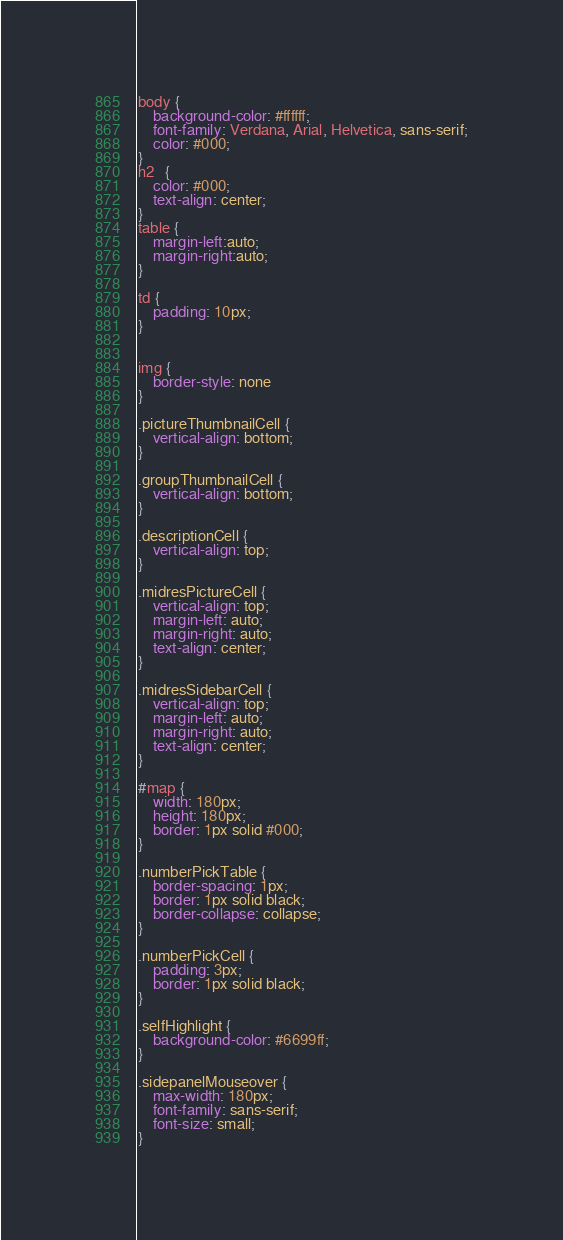Convert code to text. <code><loc_0><loc_0><loc_500><loc_500><_CSS_>body {
    background-color: #ffffff;
    font-family: Verdana, Arial, Helvetica, sans-serif;
    color: #000;
}
h2   {
    color: #000;
    text-align: center;
}
table {
    margin-left:auto;
    margin-right:auto;
}

td {
    padding: 10px;
}


img {
    border-style: none
}

.pictureThumbnailCell {
    vertical-align: bottom;
}

.groupThumbnailCell {
    vertical-align: bottom;
}

.descriptionCell {
    vertical-align: top;
}

.midresPictureCell {
    vertical-align: top;
    margin-left: auto;
    margin-right: auto;
    text-align: center;
}

.midresSidebarCell {
    vertical-align: top;
    margin-left: auto;
    margin-right: auto;
    text-align: center;
}

#map {
    width: 180px;
    height: 180px;
    border: 1px solid #000;
}

.numberPickTable {
    border-spacing: 1px;
    border: 1px solid black;
    border-collapse: collapse;
}

.numberPickCell {
    padding: 3px;
    border: 1px solid black;
}

.selfHighlight {
    background-color: #6699ff;
}

.sidepanelMouseover {
    max-width: 180px;
    font-family: sans-serif;
    font-size: small;
}
</code> 